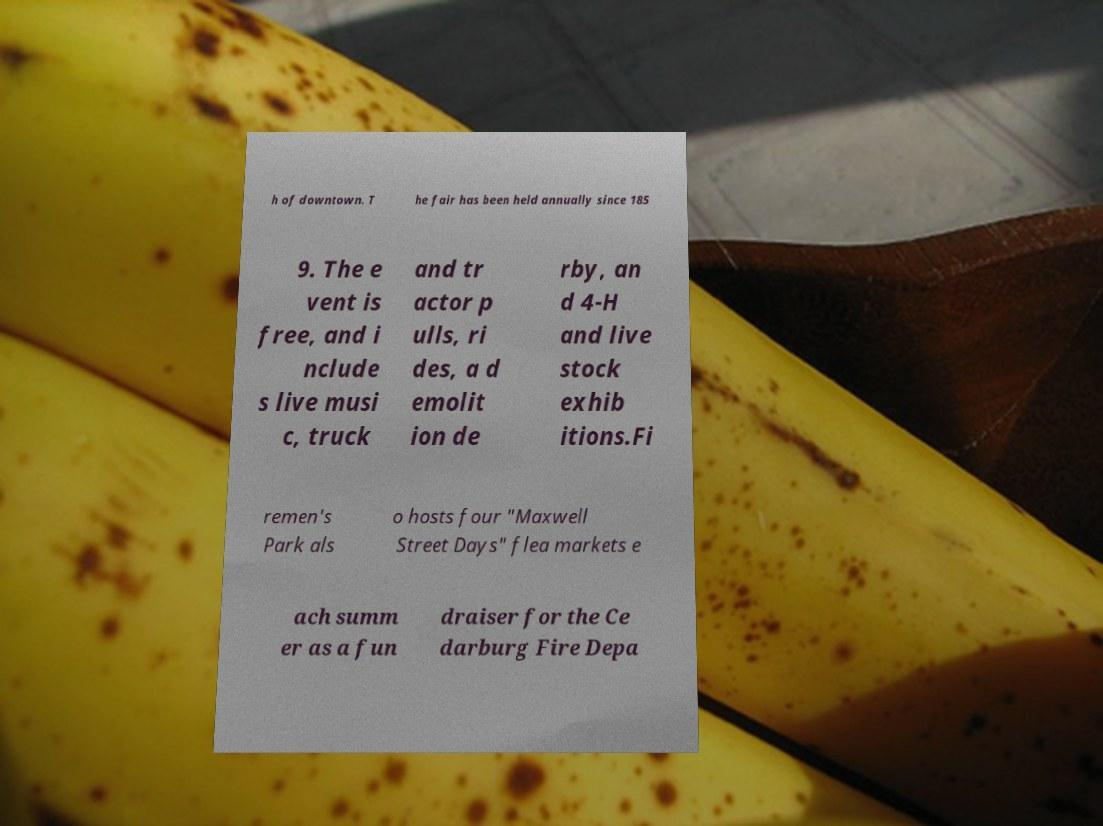Could you assist in decoding the text presented in this image and type it out clearly? h of downtown. T he fair has been held annually since 185 9. The e vent is free, and i nclude s live musi c, truck and tr actor p ulls, ri des, a d emolit ion de rby, an d 4-H and live stock exhib itions.Fi remen's Park als o hosts four "Maxwell Street Days" flea markets e ach summ er as a fun draiser for the Ce darburg Fire Depa 